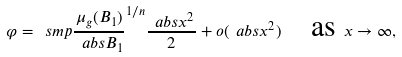<formula> <loc_0><loc_0><loc_500><loc_500>\varphi = \ s m p { \frac { \mu _ { g } ( B _ { 1 } ) } { \ a b s { B _ { 1 } } } } ^ { 1 / n } \frac { \ a b s { x } ^ { 2 } } { 2 } + o ( \ a b s { x } ^ { 2 } ) \quad \text {as } x \rightarrow \infty ,</formula> 